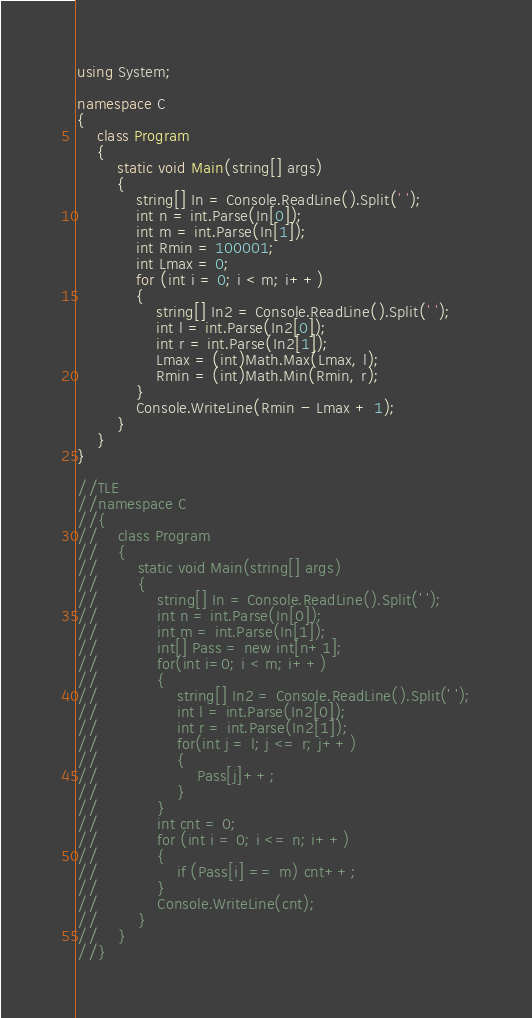Convert code to text. <code><loc_0><loc_0><loc_500><loc_500><_C#_>using System;

namespace C
{
    class Program
    {
        static void Main(string[] args)
        {
            string[] In = Console.ReadLine().Split(' ');
            int n = int.Parse(In[0]);
            int m = int.Parse(In[1]);
            int Rmin = 100001;
            int Lmax = 0;
            for (int i = 0; i < m; i++)
            {
                string[] In2 = Console.ReadLine().Split(' ');
                int l = int.Parse(In2[0]);
                int r = int.Parse(In2[1]);
                Lmax = (int)Math.Max(Lmax, l);
                Rmin = (int)Math.Min(Rmin, r);
            }
            Console.WriteLine(Rmin - Lmax + 1);
        }
    }
}

//TLE
//namespace C
//{
//    class Program
//    {
//        static void Main(string[] args)
//        {
//            string[] In = Console.ReadLine().Split(' ');
//            int n = int.Parse(In[0]);
//            int m = int.Parse(In[1]);
//            int[] Pass = new int[n+1];
//            for(int i=0; i < m; i++)
//            {
//                string[] In2 = Console.ReadLine().Split(' ');
//                int l = int.Parse(In2[0]);
//                int r = int.Parse(In2[1]);
//                for(int j = l; j <= r; j++)
//                {
//                    Pass[j]++;
//                }
//            }
//            int cnt = 0;
//            for (int i = 0; i <= n; i++)
//            {
//                if (Pass[i] == m) cnt++;
//            }
//            Console.WriteLine(cnt);
//        }
//    }
//}
</code> 